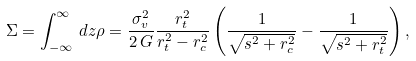<formula> <loc_0><loc_0><loc_500><loc_500>\Sigma = \int _ { - \infty } ^ { \infty } \, d z \rho = \frac { \sigma _ { v } ^ { 2 } } { 2 \, G } \frac { r _ { t } ^ { 2 } } { r _ { t } ^ { 2 } - r _ { c } ^ { 2 } } \left ( \frac { 1 } { \sqrt { s ^ { 2 } + r _ { c } ^ { 2 } } } - \frac { 1 } { \sqrt { s ^ { 2 } + r _ { t } ^ { 2 } } } \right ) ,</formula> 